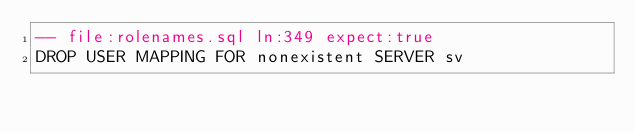Convert code to text. <code><loc_0><loc_0><loc_500><loc_500><_SQL_>-- file:rolenames.sql ln:349 expect:true
DROP USER MAPPING FOR nonexistent SERVER sv
</code> 